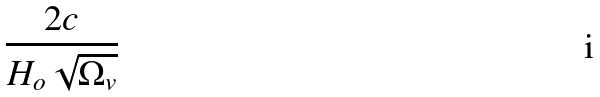Convert formula to latex. <formula><loc_0><loc_0><loc_500><loc_500>\frac { 2 c } { H _ { o } \sqrt { \Omega _ { v } } }</formula> 